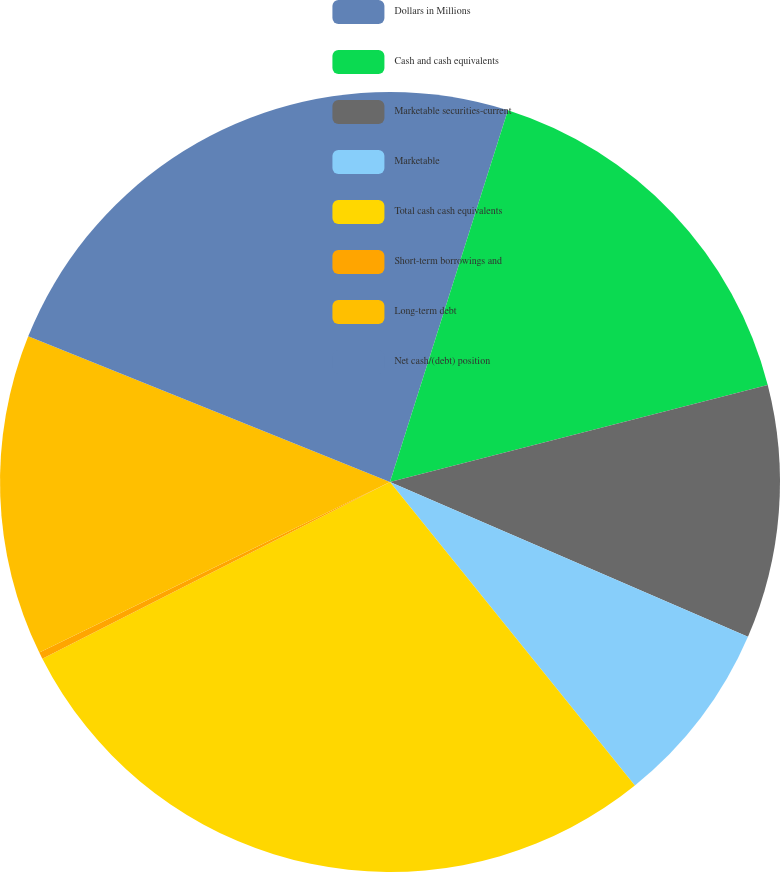Convert chart. <chart><loc_0><loc_0><loc_500><loc_500><pie_chart><fcel>Dollars in Millions<fcel>Cash and cash equivalents<fcel>Marketable securities-current<fcel>Marketable<fcel>Total cash cash equivalents<fcel>Short-term borrowings and<fcel>Long-term debt<fcel>Net cash/(debt) position<nl><fcel>4.89%<fcel>16.11%<fcel>10.5%<fcel>7.7%<fcel>28.32%<fcel>0.28%<fcel>13.3%<fcel>18.91%<nl></chart> 